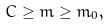<formula> <loc_0><loc_0><loc_500><loc_500>C \geq m \geq m _ { 0 } ,</formula> 